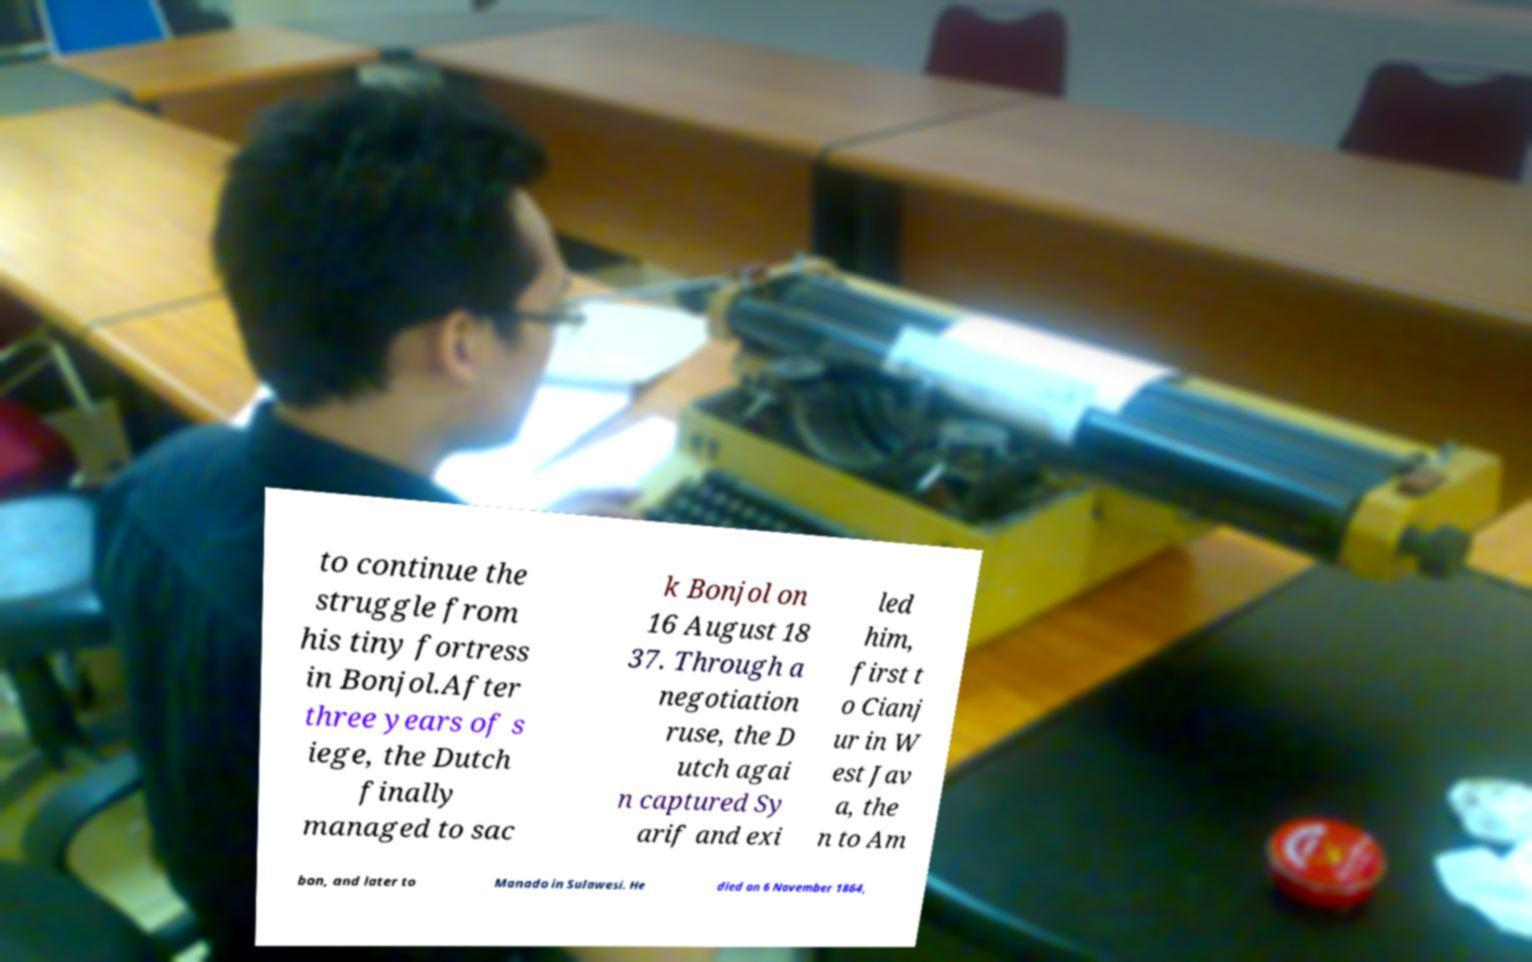Could you assist in decoding the text presented in this image and type it out clearly? to continue the struggle from his tiny fortress in Bonjol.After three years of s iege, the Dutch finally managed to sac k Bonjol on 16 August 18 37. Through a negotiation ruse, the D utch agai n captured Sy arif and exi led him, first t o Cianj ur in W est Jav a, the n to Am bon, and later to Manado in Sulawesi. He died on 6 November 1864, 